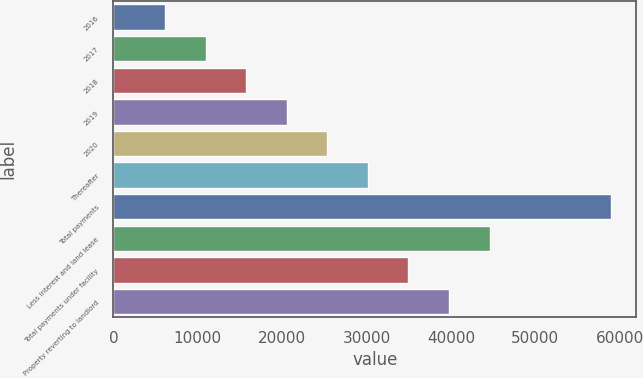Convert chart. <chart><loc_0><loc_0><loc_500><loc_500><bar_chart><fcel>2016<fcel>2017<fcel>2018<fcel>2019<fcel>2020<fcel>Thereafter<fcel>Total payments<fcel>Less interest and land lease<fcel>Total payments under facility<fcel>Property reverting to landlord<nl><fcel>6140.4<fcel>10944.8<fcel>15749.2<fcel>20553.6<fcel>25358<fcel>30162.4<fcel>58988.8<fcel>44575.6<fcel>34966.8<fcel>39771.2<nl></chart> 